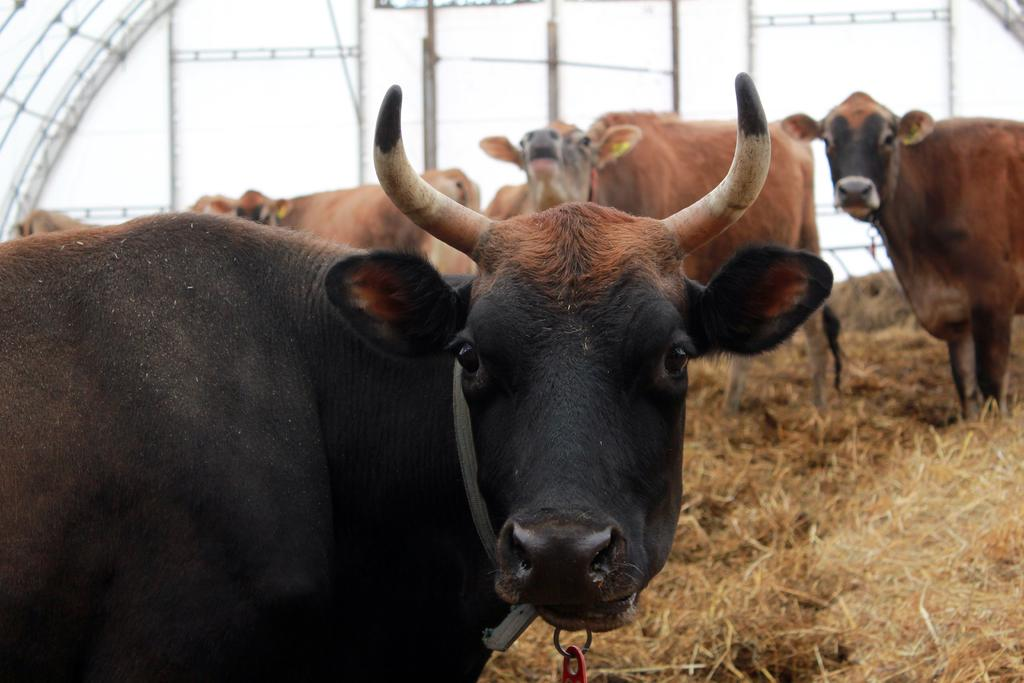What animals are in the center of the image? There are cows in the center of the image. What structure can be seen in the background of the image? There is a shed in the background of the image. What type of vegetation is visible at the bottom of the image? Dry grass is visible at the bottom of the image. What type of curve can be seen on the wing of the airplane in the image? There is no airplane or wing present in the image; it features cows and a shed. 